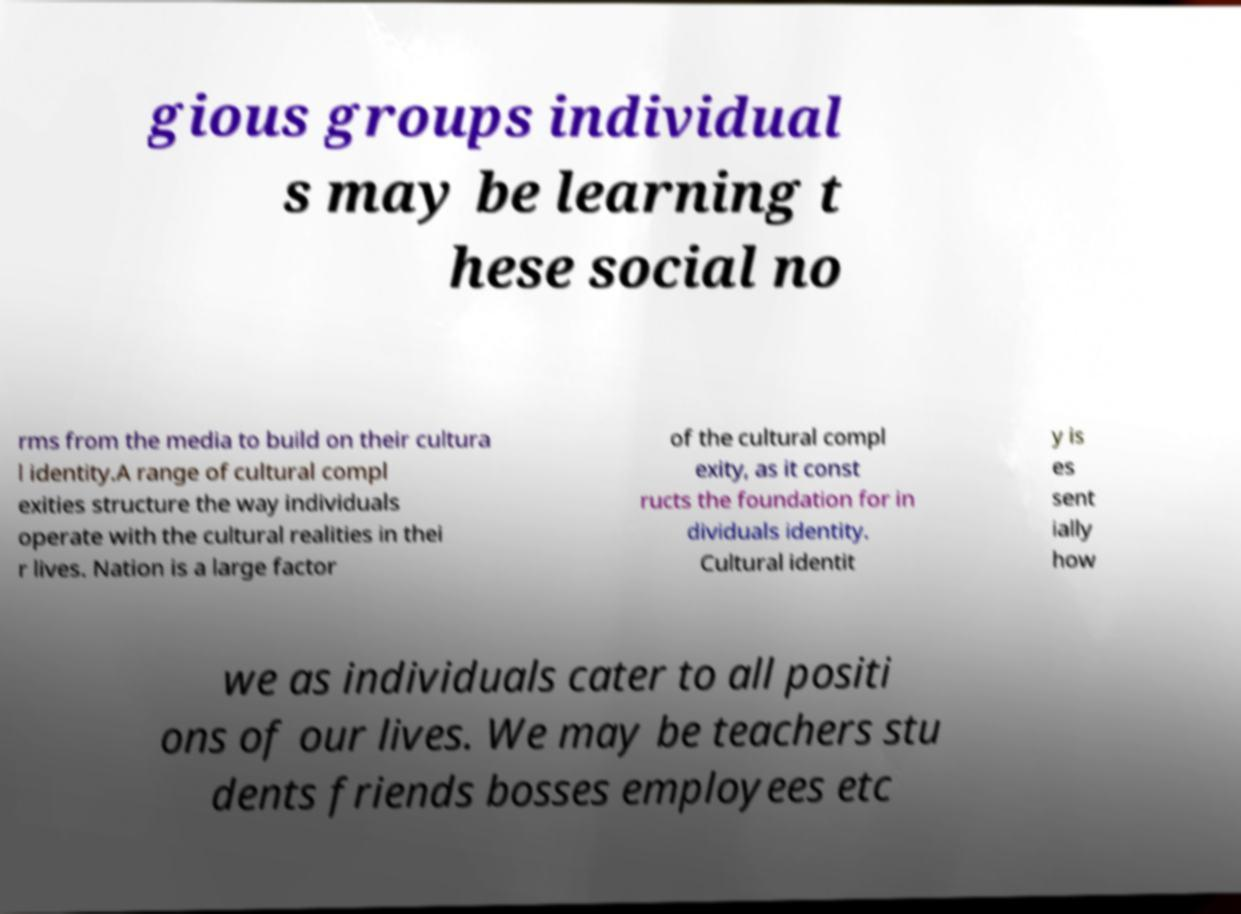Can you accurately transcribe the text from the provided image for me? gious groups individual s may be learning t hese social no rms from the media to build on their cultura l identity.A range of cultural compl exities structure the way individuals operate with the cultural realities in thei r lives. Nation is a large factor of the cultural compl exity, as it const ructs the foundation for in dividuals identity. Cultural identit y is es sent ially how we as individuals cater to all positi ons of our lives. We may be teachers stu dents friends bosses employees etc 